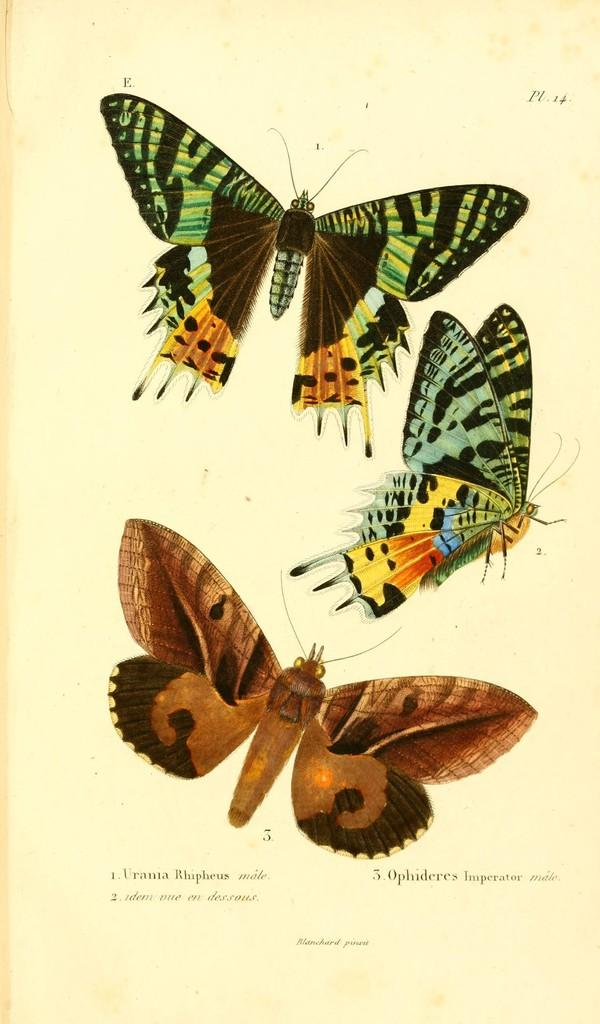What is featured in the image? There is a poster in the image. What can be seen on the poster? The poster contains pictures of butterflies. Is there any text on the poster? Yes, there is text written on the poster. What type of collar can be seen on the butterflies in the image? There are no collars present on the butterflies in the image, as butterflies do not wear collars. 